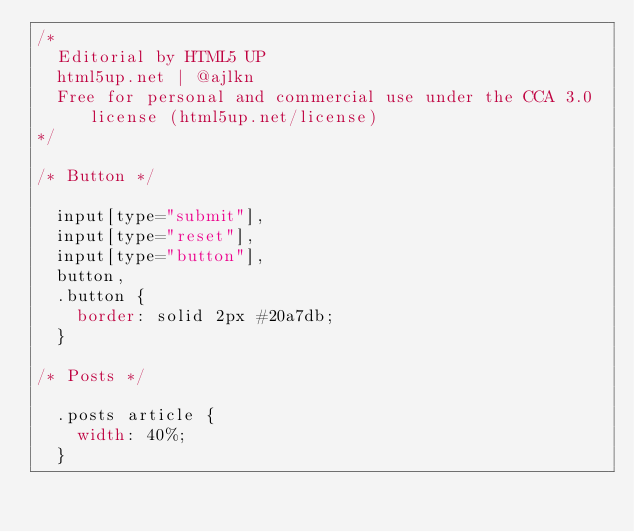Convert code to text. <code><loc_0><loc_0><loc_500><loc_500><_CSS_>/*
	Editorial by HTML5 UP
	html5up.net | @ajlkn
	Free for personal and commercial use under the CCA 3.0 license (html5up.net/license)
*/

/* Button */

	input[type="submit"],
	input[type="reset"],
	input[type="button"],
	button,
	.button {
		border: solid 2px #20a7db;
	}

/* Posts */

	.posts article {
		width: 40%;
	}
</code> 